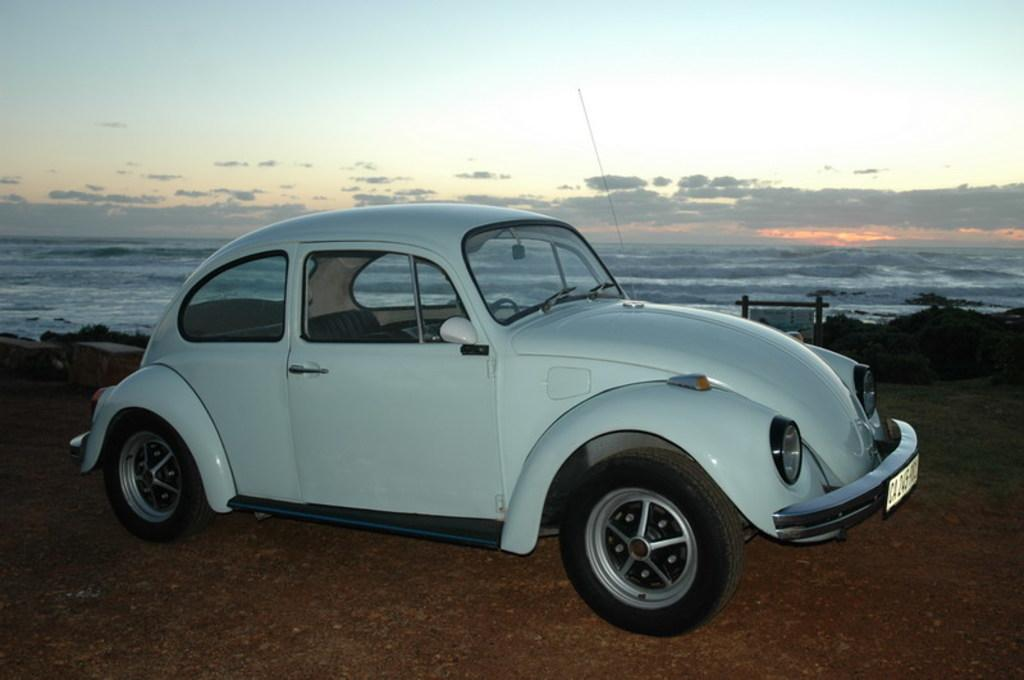What is the main subject of the picture? The main subject of the picture is a car. What else can be seen in the picture besides the car? There is a board and water visible in the picture. How would you describe the weather in the picture? The sky is cloudy in the picture, which suggests a potentially overcast or rainy day. What type of hobbies are the pizzas participating in within the image? There are no pizzas present in the image, so it's not possible to determine what hobbies they might be participating in. 